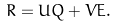Convert formula to latex. <formula><loc_0><loc_0><loc_500><loc_500>R = U Q + V E .</formula> 